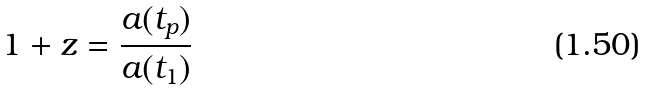<formula> <loc_0><loc_0><loc_500><loc_500>1 + z = \frac { a ( t _ { p } ) } { a ( t _ { 1 } ) }</formula> 